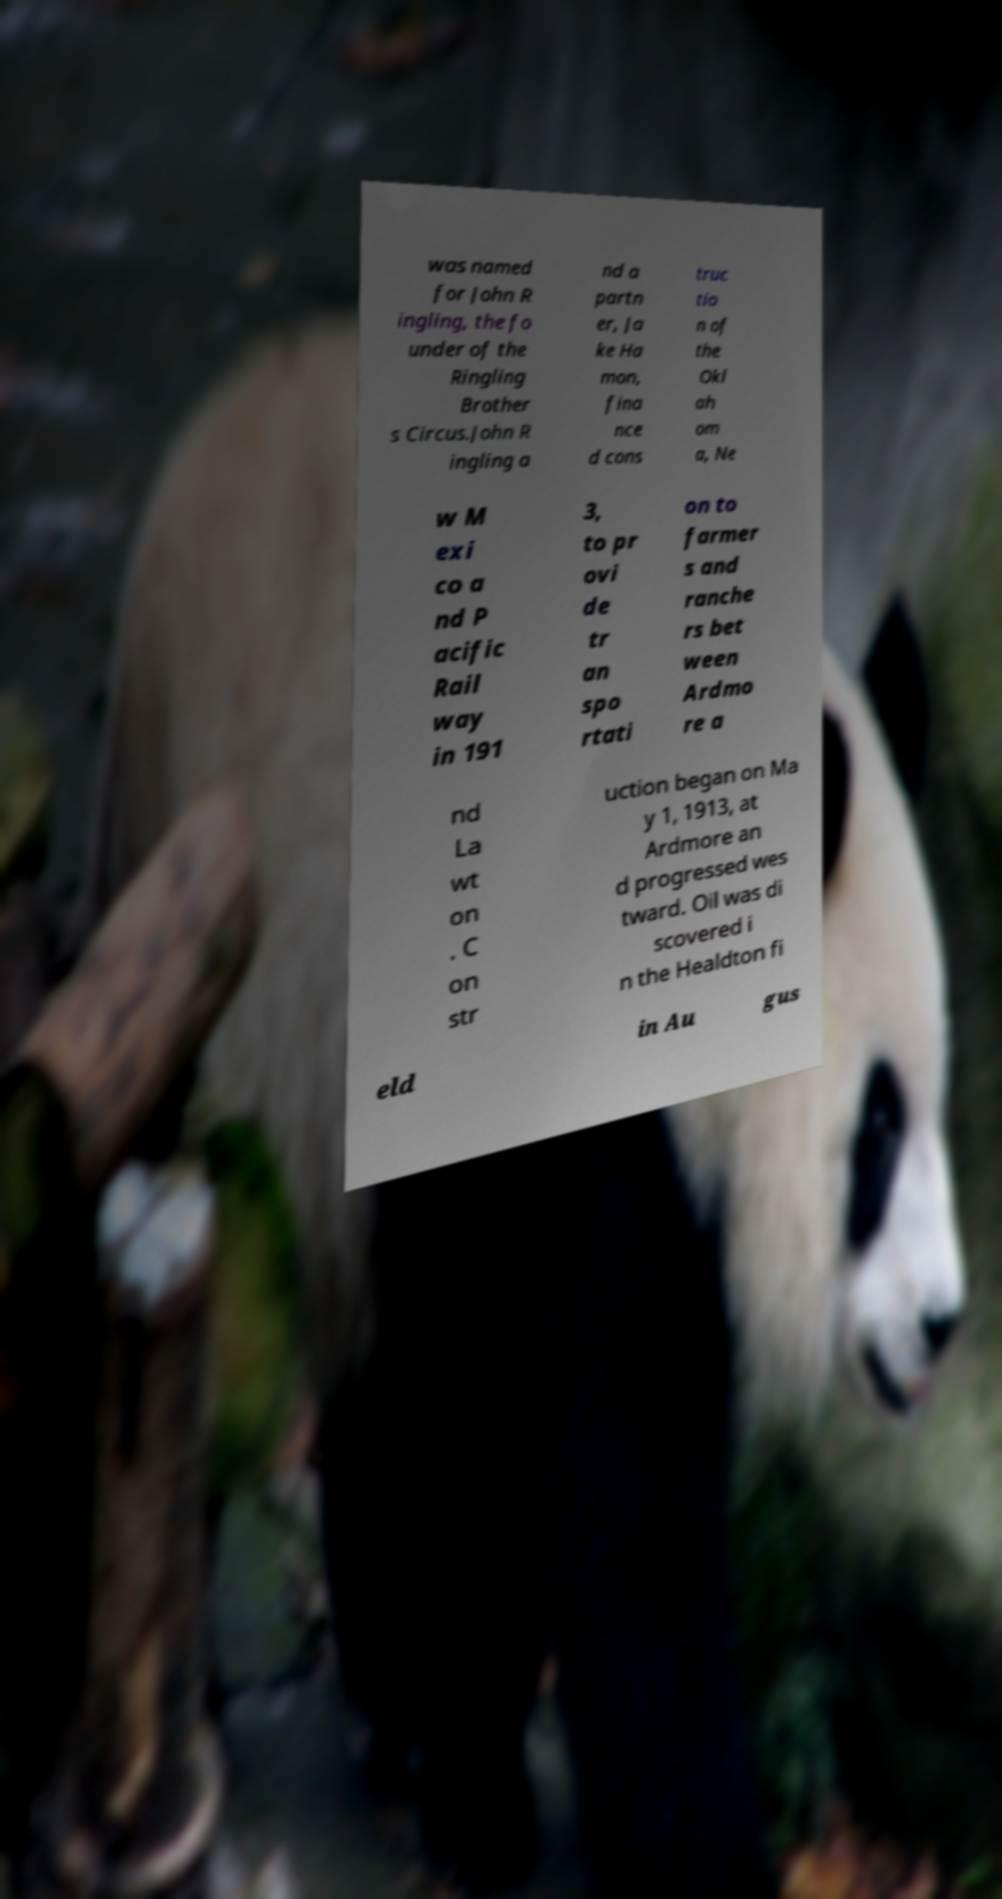Could you assist in decoding the text presented in this image and type it out clearly? was named for John R ingling, the fo under of the Ringling Brother s Circus.John R ingling a nd a partn er, Ja ke Ha mon, fina nce d cons truc tio n of the Okl ah om a, Ne w M exi co a nd P acific Rail way in 191 3, to pr ovi de tr an spo rtati on to farmer s and ranche rs bet ween Ardmo re a nd La wt on . C on str uction began on Ma y 1, 1913, at Ardmore an d progressed wes tward. Oil was di scovered i n the Healdton fi eld in Au gus 